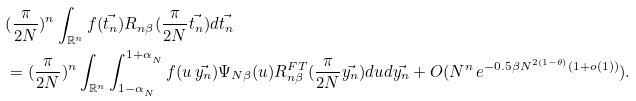Convert formula to latex. <formula><loc_0><loc_0><loc_500><loc_500>& ( \frac { \pi } { 2 N } ) ^ { n } \int _ { \mathbb { R } ^ { n } } f ( \vec { t _ { n } } ) R _ { n \beta } ( \frac { \pi } { 2 N } \vec { t _ { n } } ) d \vec { t _ { n } } \\ & = ( \frac { \pi } { 2 N } ) ^ { n } \int _ { \mathbb { R } ^ { n } } \int _ { 1 - \alpha _ { _ { N } } } ^ { 1 + \alpha _ { _ { N } } } f ( u \, \vec { y _ { n } } ) \Psi _ { N \beta } ( u ) R _ { n \beta } ^ { F T } ( \frac { \pi } { 2 N } \vec { y _ { n } } ) d u d \vec { y _ { n } } + O ( N ^ { n } \, e ^ { - 0 . 5 \beta N ^ { 2 ( 1 - \theta ) } ( 1 + o ( 1 ) ) } ) .</formula> 